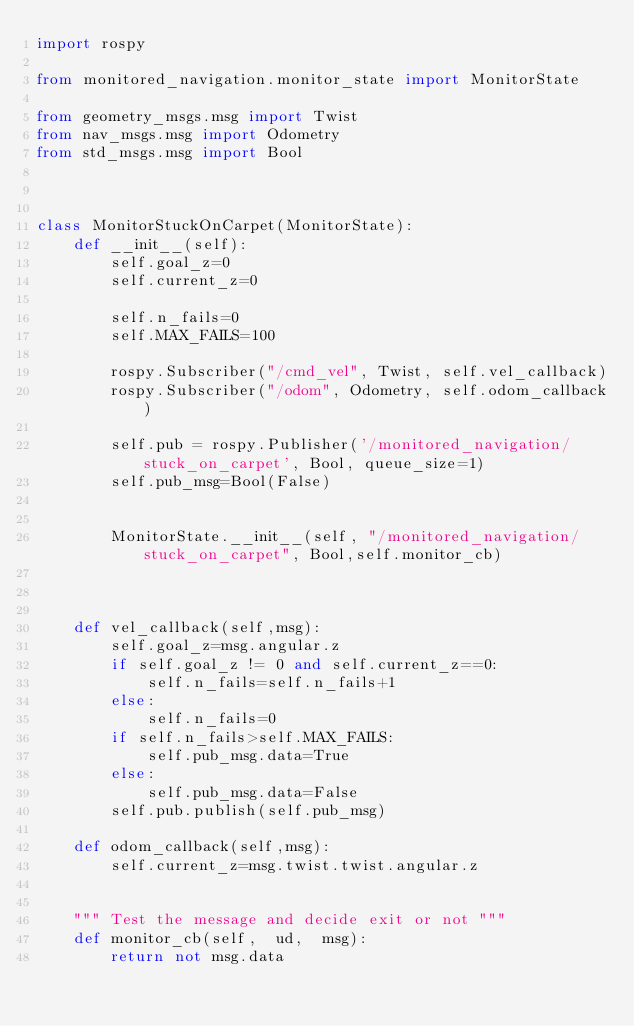Convert code to text. <code><loc_0><loc_0><loc_500><loc_500><_Python_>import rospy

from monitored_navigation.monitor_state import MonitorState

from geometry_msgs.msg import Twist
from nav_msgs.msg import Odometry
from std_msgs.msg import Bool



class MonitorStuckOnCarpet(MonitorState):
    def __init__(self):
        self.goal_z=0
        self.current_z=0
        
        self.n_fails=0
        self.MAX_FAILS=100
  
        rospy.Subscriber("/cmd_vel", Twist, self.vel_callback)   
        rospy.Subscriber("/odom", Odometry, self.odom_callback)
 
        self.pub = rospy.Publisher('/monitored_navigation/stuck_on_carpet', Bool, queue_size=1)
        self.pub_msg=Bool(False)
        
        
        MonitorState.__init__(self, "/monitored_navigation/stuck_on_carpet", Bool,self.monitor_cb)
        


    def vel_callback(self,msg):
        self.goal_z=msg.angular.z
        if self.goal_z != 0 and self.current_z==0:
            self.n_fails=self.n_fails+1
        else:
            self.n_fails=0
        if self.n_fails>self.MAX_FAILS:
            self.pub_msg.data=True
        else:
            self.pub_msg.data=False
        self.pub.publish(self.pub_msg)    

    def odom_callback(self,msg):
        self.current_z=msg.twist.twist.angular.z
        

    """ Test the message and decide exit or not """
    def monitor_cb(self,  ud,  msg):
        return not msg.data





</code> 